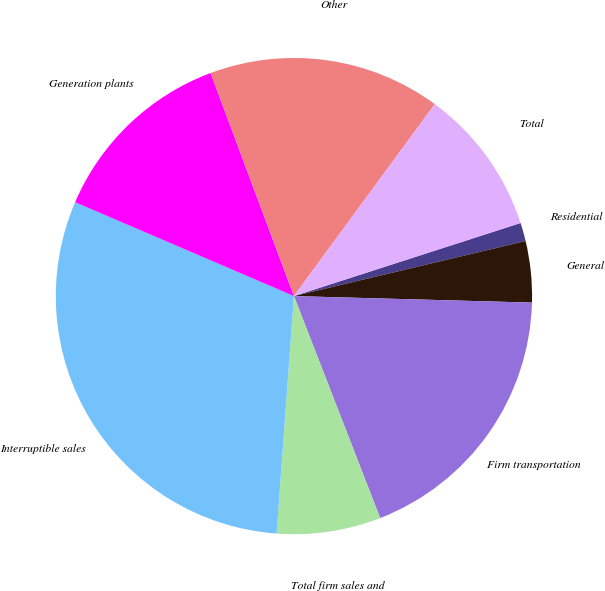<chart> <loc_0><loc_0><loc_500><loc_500><pie_chart><fcel>Residential<fcel>General<fcel>Firm transportation<fcel>Total firm sales and<fcel>Interruptible sales<fcel>Generation plants<fcel>Other<fcel>Total<nl><fcel>1.25%<fcel>4.15%<fcel>18.67%<fcel>7.06%<fcel>30.29%<fcel>12.86%<fcel>15.77%<fcel>9.96%<nl></chart> 